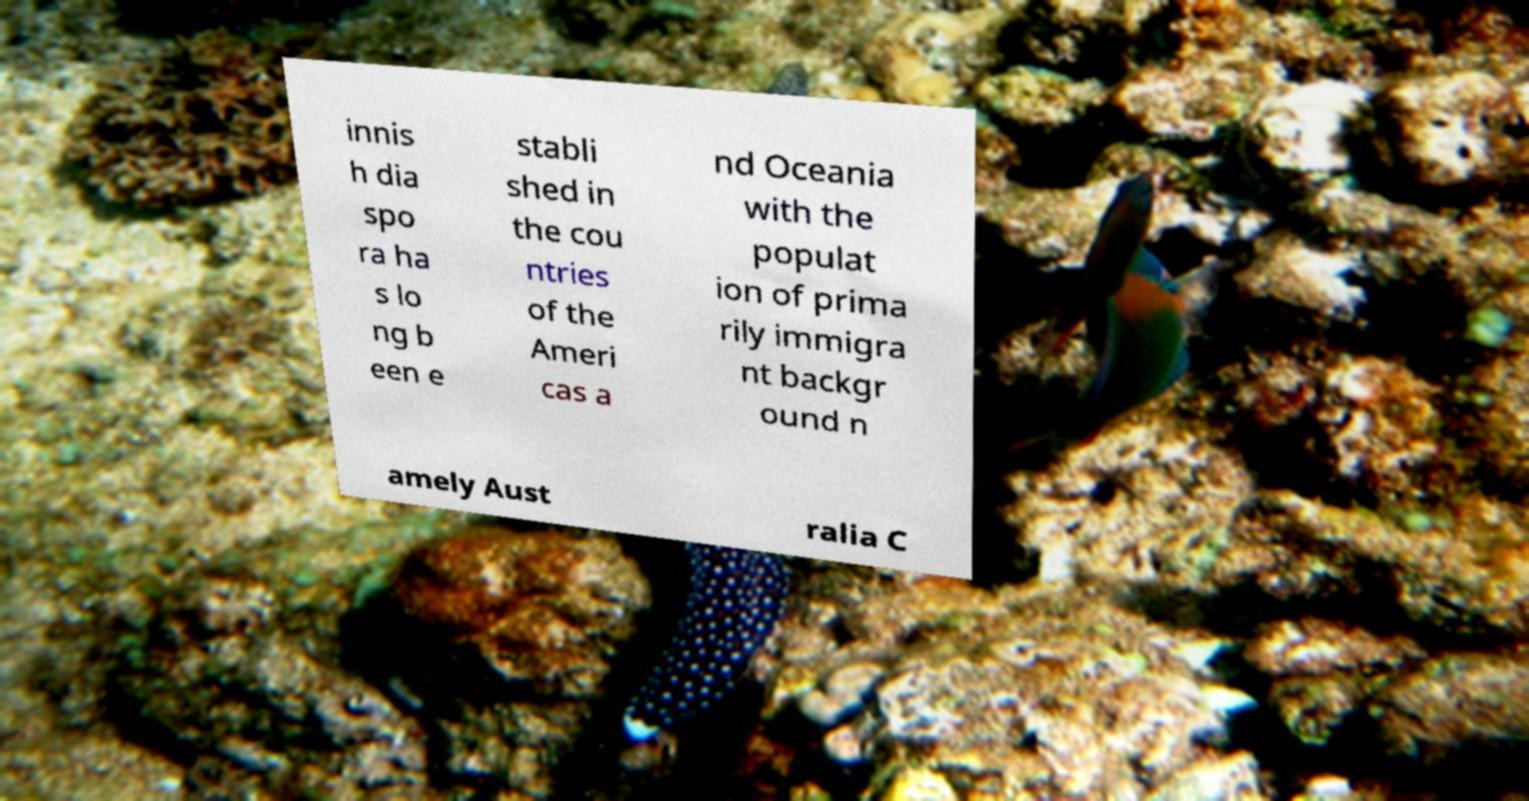What messages or text are displayed in this image? I need them in a readable, typed format. innis h dia spo ra ha s lo ng b een e stabli shed in the cou ntries of the Ameri cas a nd Oceania with the populat ion of prima rily immigra nt backgr ound n amely Aust ralia C 